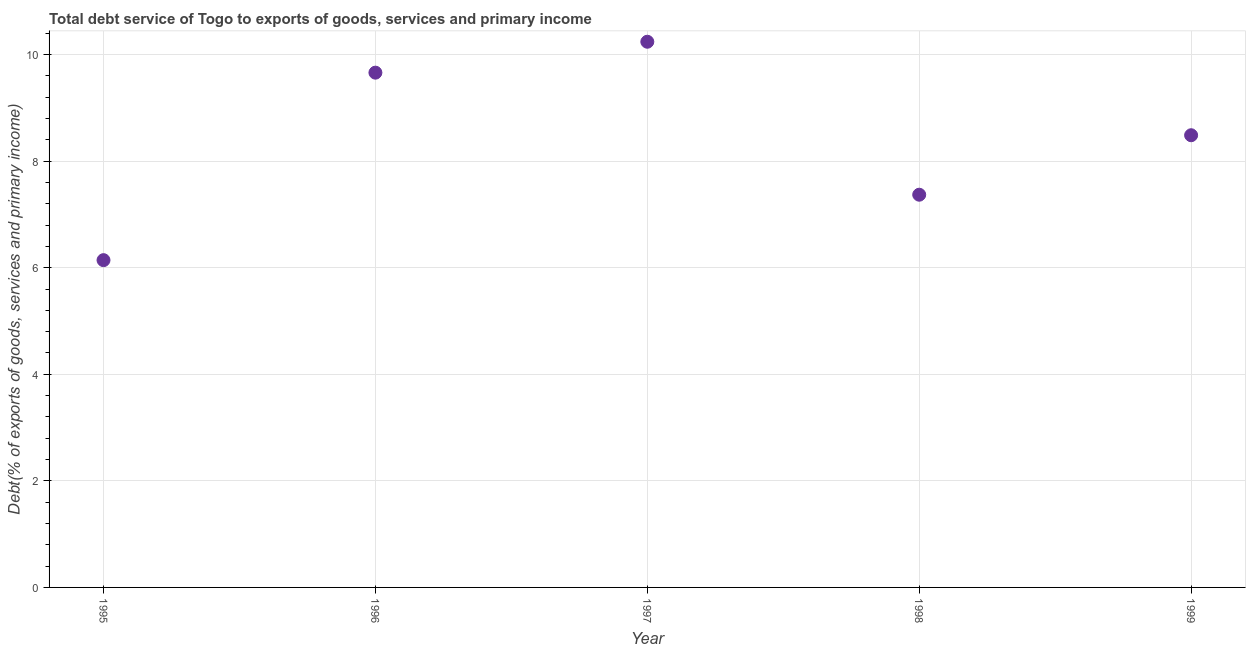What is the total debt service in 1999?
Provide a short and direct response. 8.49. Across all years, what is the maximum total debt service?
Give a very brief answer. 10.24. Across all years, what is the minimum total debt service?
Offer a very short reply. 6.14. In which year was the total debt service maximum?
Your answer should be very brief. 1997. In which year was the total debt service minimum?
Your response must be concise. 1995. What is the sum of the total debt service?
Offer a very short reply. 41.9. What is the difference between the total debt service in 1995 and 1998?
Your answer should be compact. -1.23. What is the average total debt service per year?
Ensure brevity in your answer.  8.38. What is the median total debt service?
Your response must be concise. 8.49. What is the ratio of the total debt service in 1996 to that in 1998?
Offer a terse response. 1.31. Is the difference between the total debt service in 1996 and 1998 greater than the difference between any two years?
Give a very brief answer. No. What is the difference between the highest and the second highest total debt service?
Ensure brevity in your answer.  0.58. Is the sum of the total debt service in 1995 and 1996 greater than the maximum total debt service across all years?
Your answer should be compact. Yes. What is the difference between the highest and the lowest total debt service?
Give a very brief answer. 4.1. In how many years, is the total debt service greater than the average total debt service taken over all years?
Your response must be concise. 3. Does the total debt service monotonically increase over the years?
Ensure brevity in your answer.  No. How many dotlines are there?
Provide a short and direct response. 1. How many years are there in the graph?
Ensure brevity in your answer.  5. What is the title of the graph?
Your answer should be very brief. Total debt service of Togo to exports of goods, services and primary income. What is the label or title of the X-axis?
Your response must be concise. Year. What is the label or title of the Y-axis?
Keep it short and to the point. Debt(% of exports of goods, services and primary income). What is the Debt(% of exports of goods, services and primary income) in 1995?
Your response must be concise. 6.14. What is the Debt(% of exports of goods, services and primary income) in 1996?
Offer a very short reply. 9.66. What is the Debt(% of exports of goods, services and primary income) in 1997?
Your answer should be compact. 10.24. What is the Debt(% of exports of goods, services and primary income) in 1998?
Provide a succinct answer. 7.37. What is the Debt(% of exports of goods, services and primary income) in 1999?
Your response must be concise. 8.49. What is the difference between the Debt(% of exports of goods, services and primary income) in 1995 and 1996?
Make the answer very short. -3.52. What is the difference between the Debt(% of exports of goods, services and primary income) in 1995 and 1997?
Ensure brevity in your answer.  -4.1. What is the difference between the Debt(% of exports of goods, services and primary income) in 1995 and 1998?
Give a very brief answer. -1.23. What is the difference between the Debt(% of exports of goods, services and primary income) in 1995 and 1999?
Your answer should be very brief. -2.34. What is the difference between the Debt(% of exports of goods, services and primary income) in 1996 and 1997?
Give a very brief answer. -0.58. What is the difference between the Debt(% of exports of goods, services and primary income) in 1996 and 1998?
Your response must be concise. 2.29. What is the difference between the Debt(% of exports of goods, services and primary income) in 1996 and 1999?
Keep it short and to the point. 1.17. What is the difference between the Debt(% of exports of goods, services and primary income) in 1997 and 1998?
Offer a terse response. 2.87. What is the difference between the Debt(% of exports of goods, services and primary income) in 1997 and 1999?
Keep it short and to the point. 1.75. What is the difference between the Debt(% of exports of goods, services and primary income) in 1998 and 1999?
Your response must be concise. -1.12. What is the ratio of the Debt(% of exports of goods, services and primary income) in 1995 to that in 1996?
Your answer should be very brief. 0.64. What is the ratio of the Debt(% of exports of goods, services and primary income) in 1995 to that in 1998?
Your answer should be very brief. 0.83. What is the ratio of the Debt(% of exports of goods, services and primary income) in 1995 to that in 1999?
Keep it short and to the point. 0.72. What is the ratio of the Debt(% of exports of goods, services and primary income) in 1996 to that in 1997?
Give a very brief answer. 0.94. What is the ratio of the Debt(% of exports of goods, services and primary income) in 1996 to that in 1998?
Your answer should be compact. 1.31. What is the ratio of the Debt(% of exports of goods, services and primary income) in 1996 to that in 1999?
Provide a short and direct response. 1.14. What is the ratio of the Debt(% of exports of goods, services and primary income) in 1997 to that in 1998?
Give a very brief answer. 1.39. What is the ratio of the Debt(% of exports of goods, services and primary income) in 1997 to that in 1999?
Your answer should be compact. 1.21. What is the ratio of the Debt(% of exports of goods, services and primary income) in 1998 to that in 1999?
Ensure brevity in your answer.  0.87. 